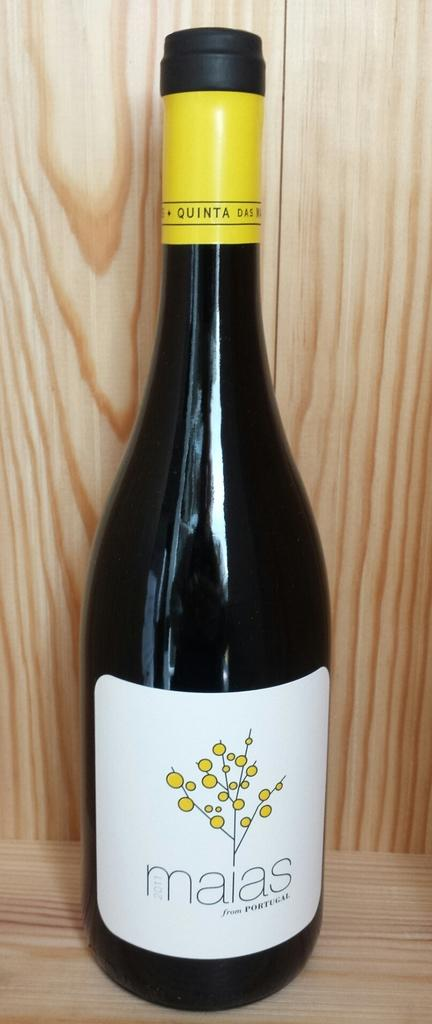What is the color of the juice bottle in the image? The juice bottle in the image is black. Where is the juice bottle located in the image? The juice bottle is placed on a wooden table top. What type of brick is used to construct the coach in the image? There is no coach or brick present in the image; it only features a black juice bottle on a wooden table top. 